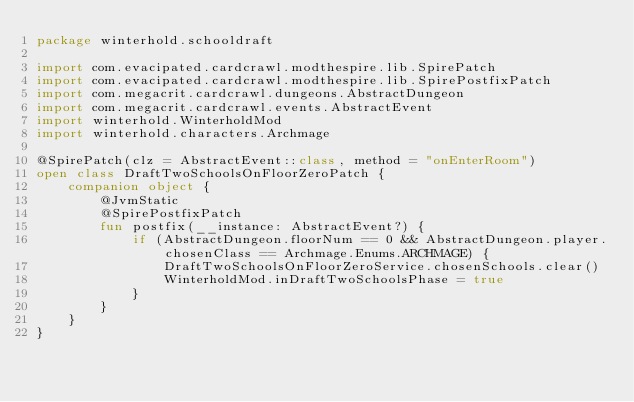<code> <loc_0><loc_0><loc_500><loc_500><_Kotlin_>package winterhold.schooldraft

import com.evacipated.cardcrawl.modthespire.lib.SpirePatch
import com.evacipated.cardcrawl.modthespire.lib.SpirePostfixPatch
import com.megacrit.cardcrawl.dungeons.AbstractDungeon
import com.megacrit.cardcrawl.events.AbstractEvent
import winterhold.WinterholdMod
import winterhold.characters.Archmage

@SpirePatch(clz = AbstractEvent::class, method = "onEnterRoom")
open class DraftTwoSchoolsOnFloorZeroPatch {
    companion object {
        @JvmStatic
        @SpirePostfixPatch
        fun postfix(__instance: AbstractEvent?) {
            if (AbstractDungeon.floorNum == 0 && AbstractDungeon.player.chosenClass == Archmage.Enums.ARCHMAGE) {
                DraftTwoSchoolsOnFloorZeroService.chosenSchools.clear()
                WinterholdMod.inDraftTwoSchoolsPhase = true
            }
        }
    }
}</code> 